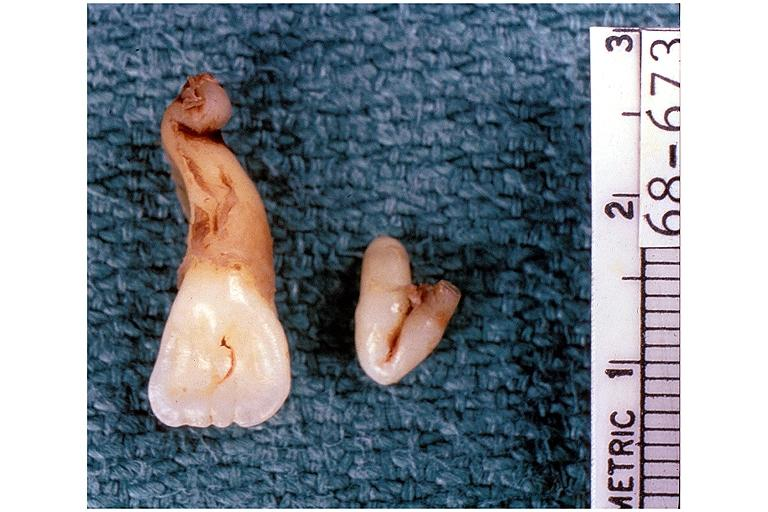what does this image show?
Answer the question using a single word or phrase. Dilaceration 